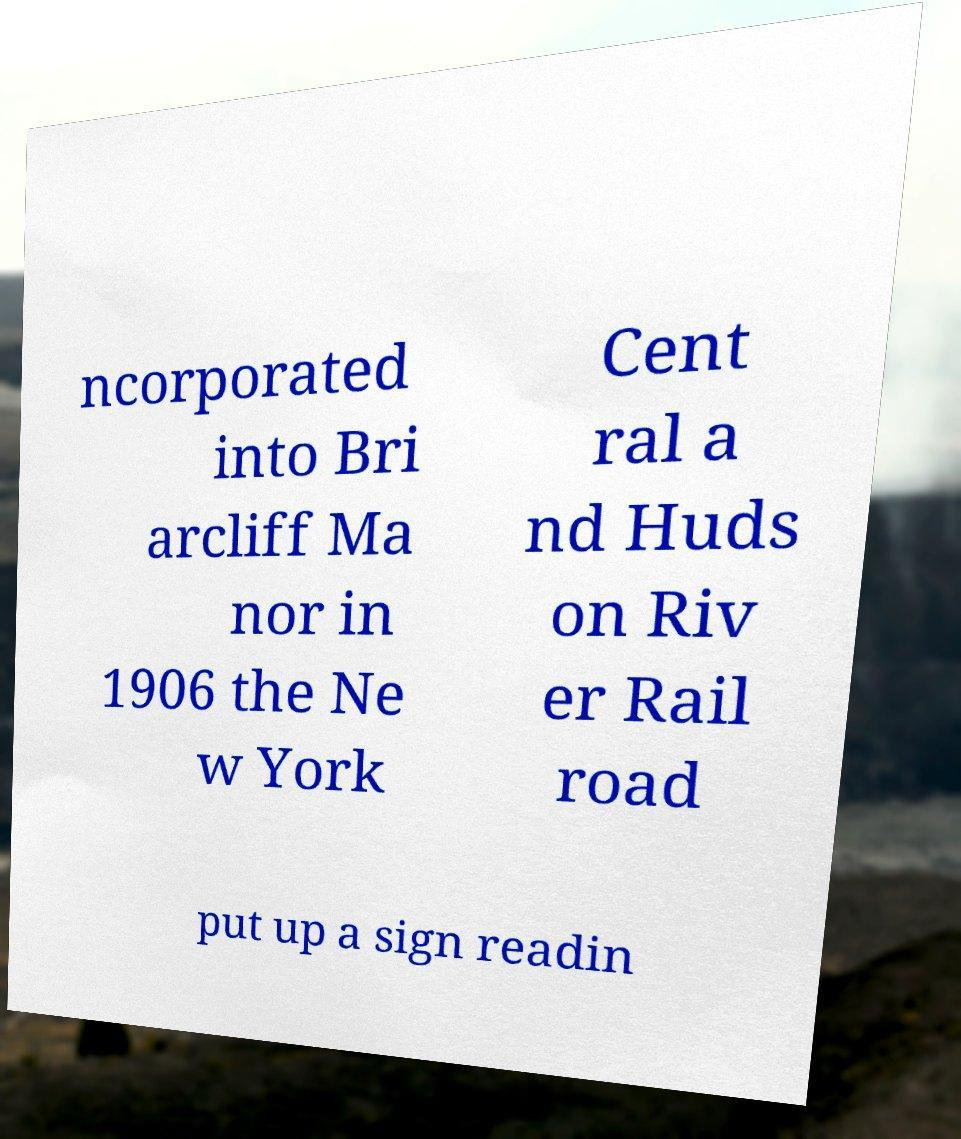I need the written content from this picture converted into text. Can you do that? ncorporated into Bri arcliff Ma nor in 1906 the Ne w York Cent ral a nd Huds on Riv er Rail road put up a sign readin 